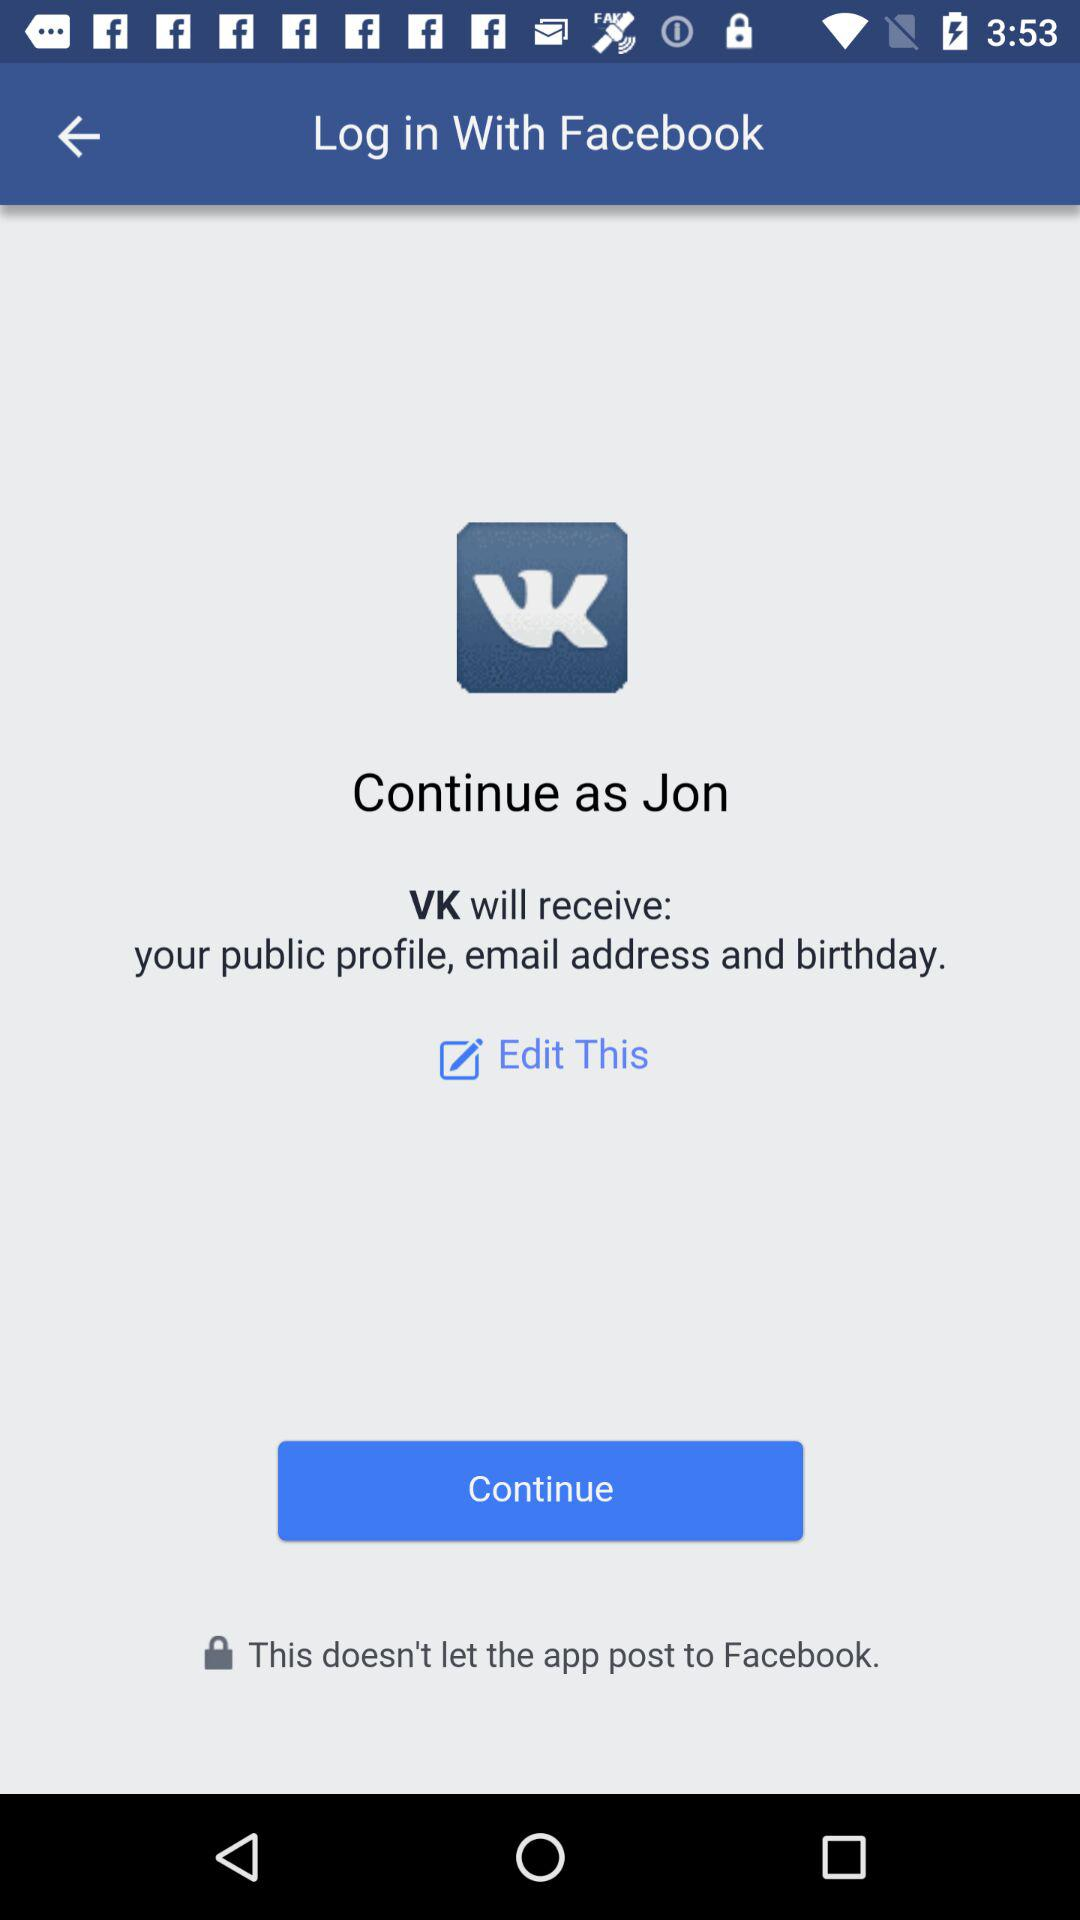What is the user name? The user name is Jon. 